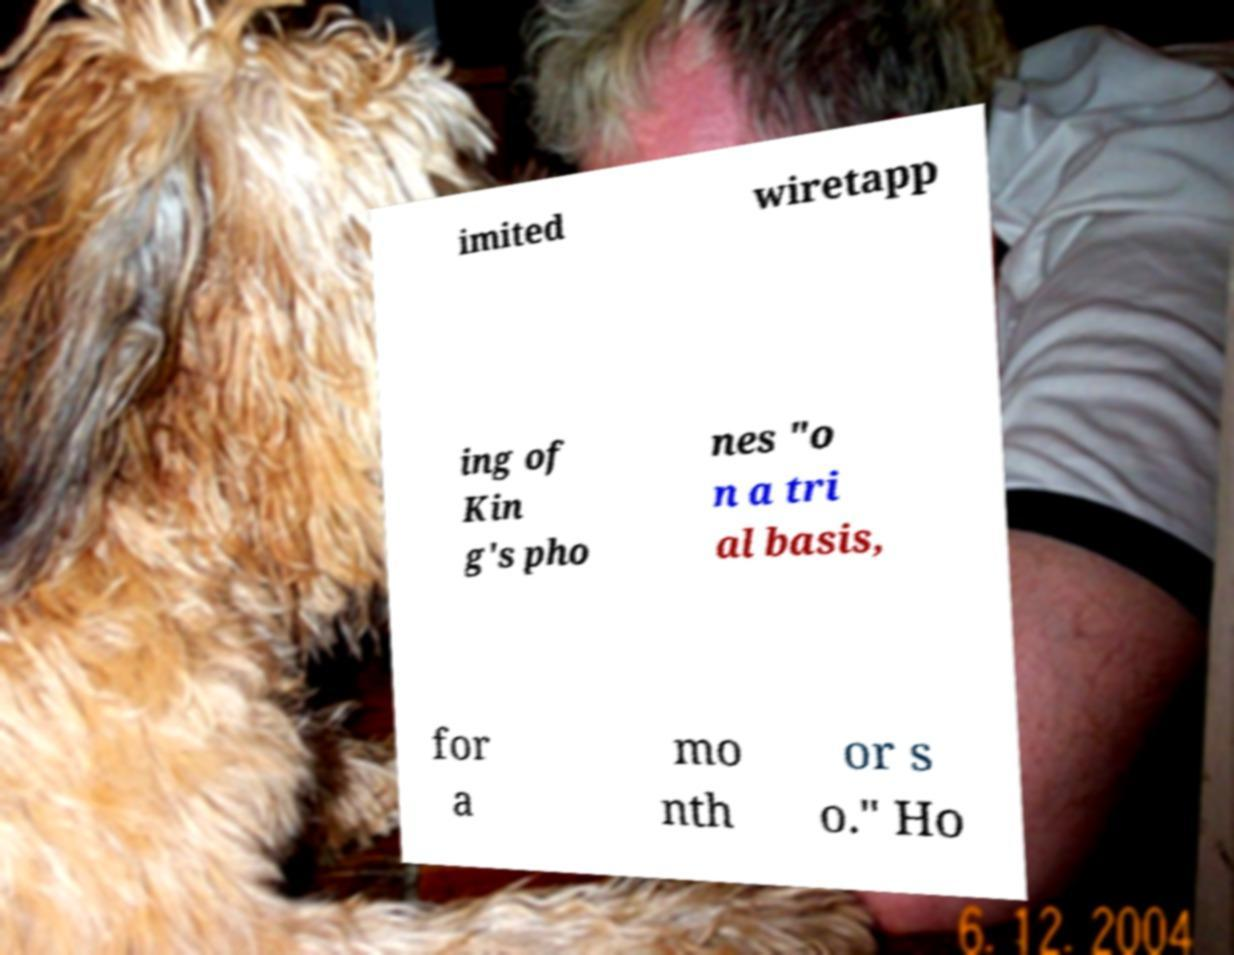I need the written content from this picture converted into text. Can you do that? imited wiretapp ing of Kin g's pho nes "o n a tri al basis, for a mo nth or s o." Ho 